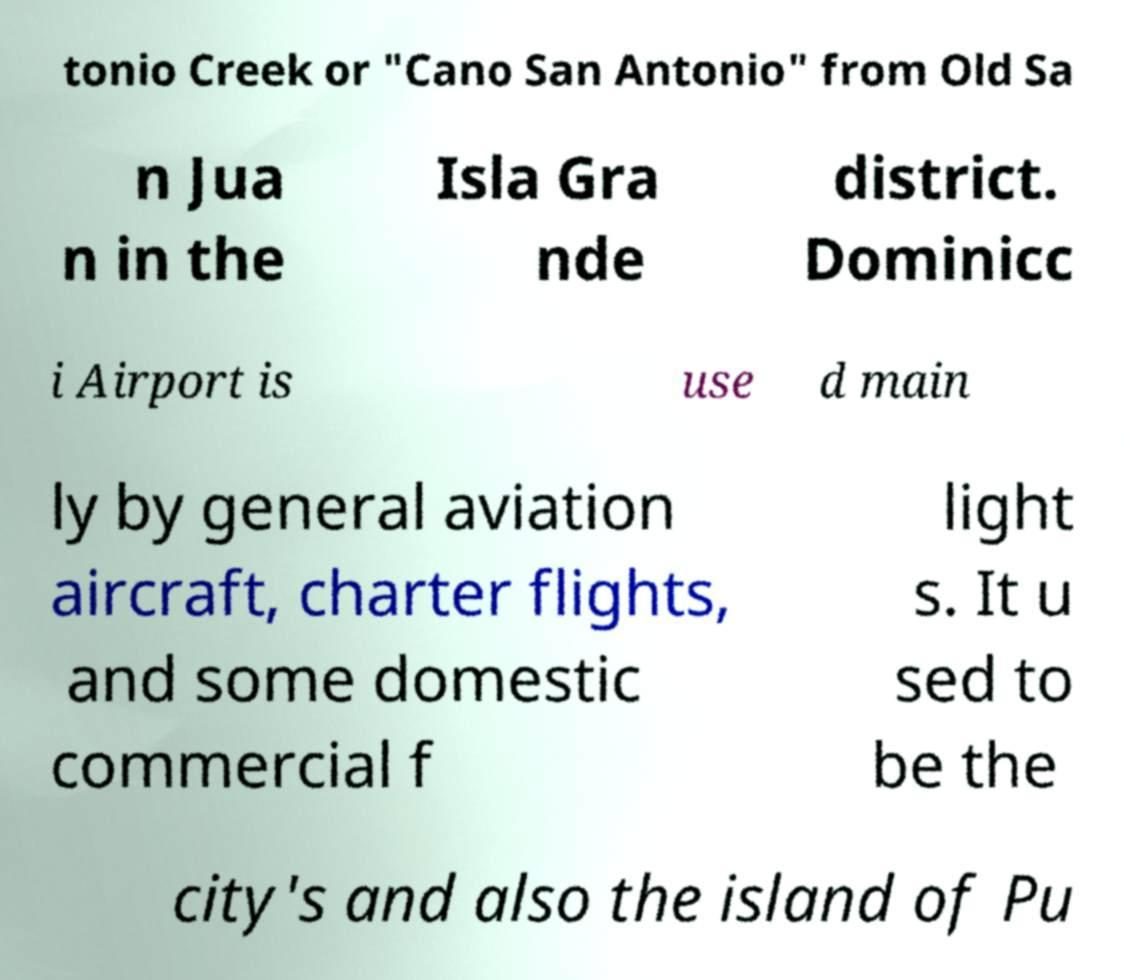Please read and relay the text visible in this image. What does it say? tonio Creek or "Cano San Antonio" from Old Sa n Jua n in the Isla Gra nde district. Dominicc i Airport is use d main ly by general aviation aircraft, charter flights, and some domestic commercial f light s. It u sed to be the city's and also the island of Pu 